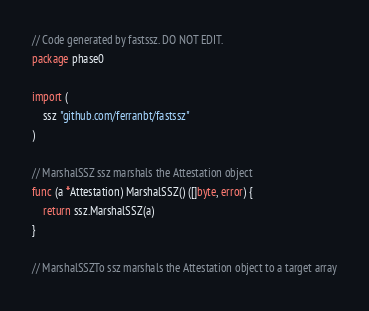<code> <loc_0><loc_0><loc_500><loc_500><_Go_>// Code generated by fastssz. DO NOT EDIT.
package phase0

import (
	ssz "github.com/ferranbt/fastssz"
)

// MarshalSSZ ssz marshals the Attestation object
func (a *Attestation) MarshalSSZ() ([]byte, error) {
	return ssz.MarshalSSZ(a)
}

// MarshalSSZTo ssz marshals the Attestation object to a target array</code> 